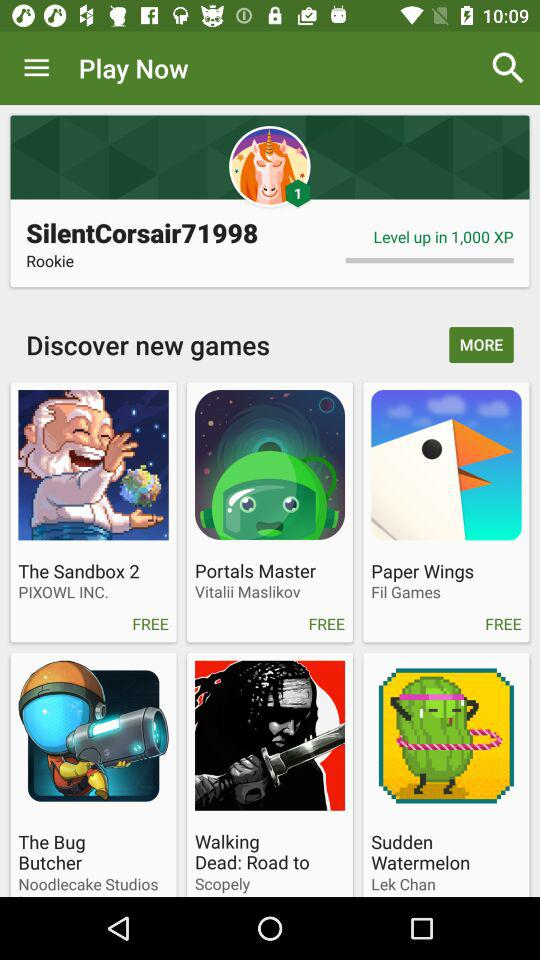What are the different games for free? The different games for free are "The Sandbox 2", "Portals Master", and "Paper Wings". 